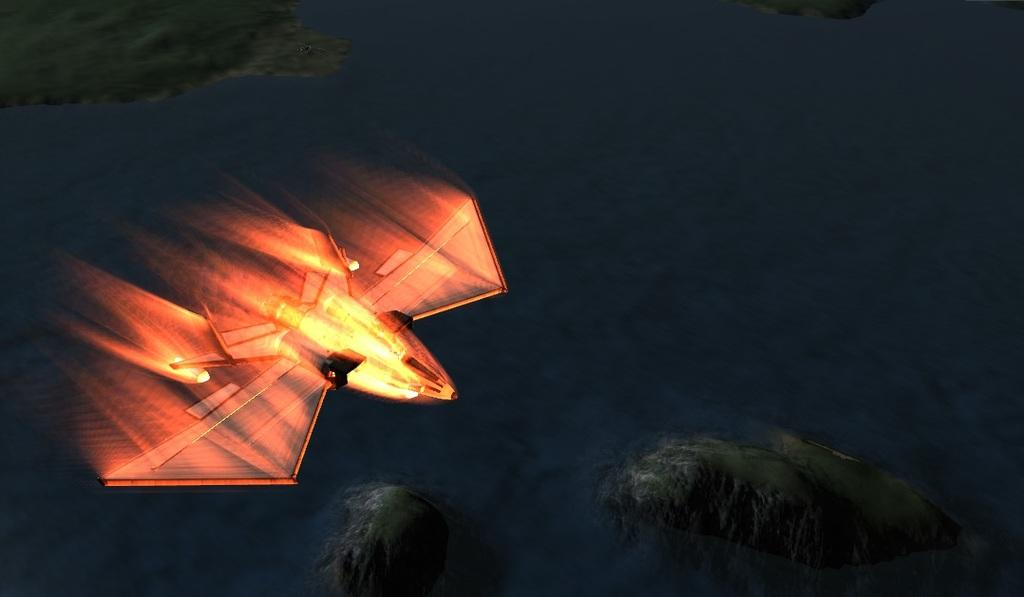What is the main subject of the image? The main subject of the image is an animated picture of an airplane. What type of wool can be seen in the image? There is no wool present in the image; it features an animated picture of an airplane. How many mines are visible in the image? There are no mines present in the image; it features an animated picture of an airplane. 